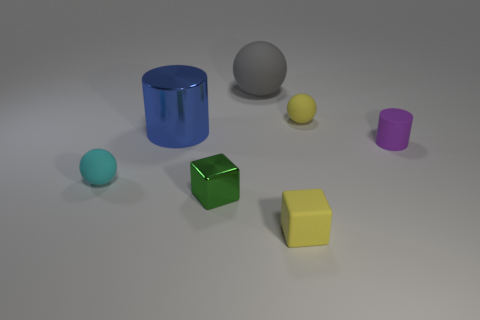What materials do the objects in the image appear to be made from? The objects seem to have different materials. The cylinder and the cube appear glossy, suggesting they might be made of plastic or some polished metal. The gray ball has a matte finish and might be made of stone or clay. The small sphere looks metallic, and the discs could be either plastic or metal due to their sheen. 